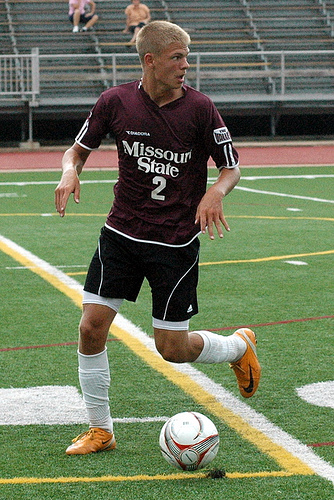<image>
Is the man behind the ball? Yes. From this viewpoint, the man is positioned behind the ball, with the ball partially or fully occluding the man. 